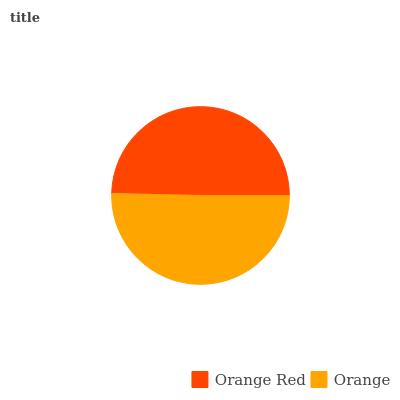Is Orange Red the minimum?
Answer yes or no. Yes. Is Orange the maximum?
Answer yes or no. Yes. Is Orange the minimum?
Answer yes or no. No. Is Orange greater than Orange Red?
Answer yes or no. Yes. Is Orange Red less than Orange?
Answer yes or no. Yes. Is Orange Red greater than Orange?
Answer yes or no. No. Is Orange less than Orange Red?
Answer yes or no. No. Is Orange the high median?
Answer yes or no. Yes. Is Orange Red the low median?
Answer yes or no. Yes. Is Orange Red the high median?
Answer yes or no. No. Is Orange the low median?
Answer yes or no. No. 